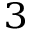<formula> <loc_0><loc_0><loc_500><loc_500>^ { 3 }</formula> 